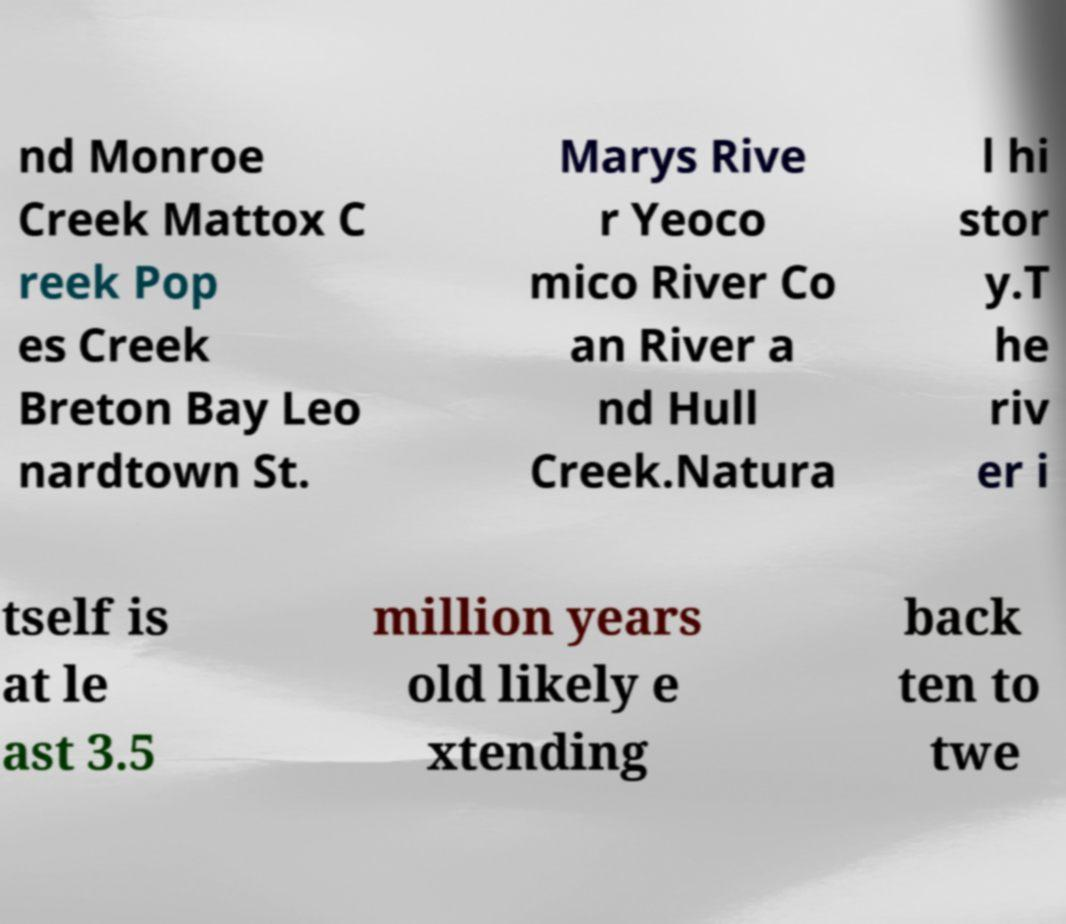Please read and relay the text visible in this image. What does it say? nd Monroe Creek Mattox C reek Pop es Creek Breton Bay Leo nardtown St. Marys Rive r Yeoco mico River Co an River a nd Hull Creek.Natura l hi stor y.T he riv er i tself is at le ast 3.5 million years old likely e xtending back ten to twe 